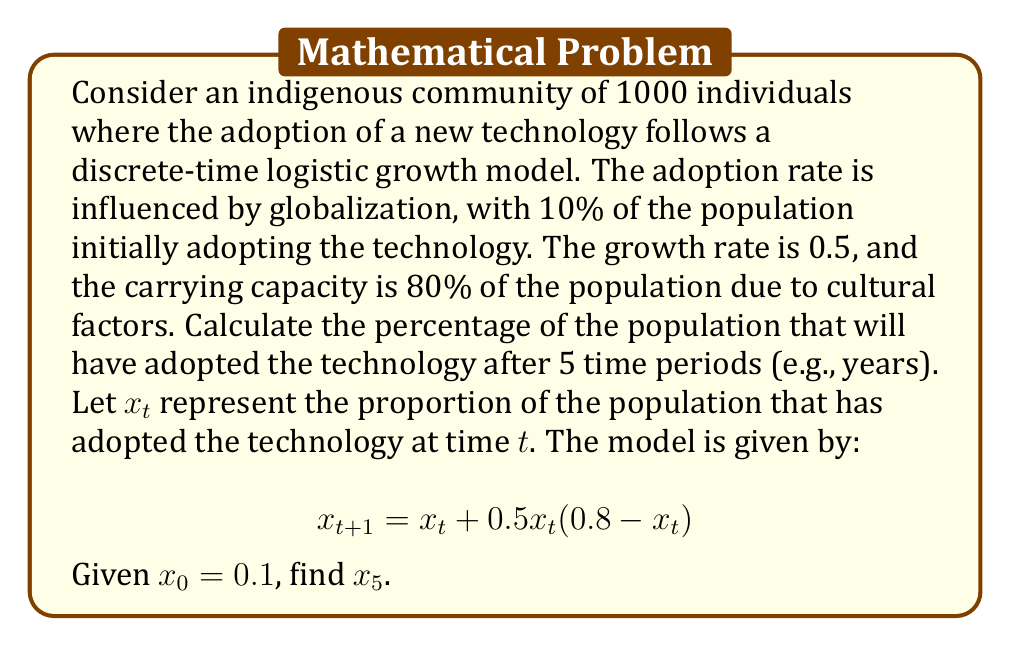Help me with this question. To solve this problem, we need to iterate the given discrete-time dynamical system for 5 time periods. Let's calculate step by step:

1) We start with $x_0 = 0.1$

2) For $t = 0$ to $t = 4$, we calculate $x_{t+1}$ using the formula:
   $$x_{t+1} = x_t + 0.5x_t(0.8 - x_t)$$

3) Let's calculate each step:

   For $t = 0$:
   $$x_1 = 0.1 + 0.5(0.1)(0.8 - 0.1) = 0.1 + 0.035 = 0.135$$

   For $t = 1$:
   $$x_2 = 0.135 + 0.5(0.135)(0.8 - 0.135) = 0.135 + 0.04486875 = 0.17986875$$

   For $t = 2$:
   $$x_3 = 0.17986875 + 0.5(0.17986875)(0.8 - 0.17986875) = 0.23580728$$

   For $t = 3$:
   $$x_4 = 0.23580728 + 0.5(0.23580728)(0.8 - 0.23580728) = 0.30284448$$

   For $t = 4$:
   $$x_5 = 0.30284448 + 0.5(0.30284448)(0.8 - 0.30284448) = 0.37929337$$

4) Therefore, after 5 time periods, $x_5 \approx 0.37929337$

5) To convert this to a percentage, we multiply by 100:
   $0.37929337 * 100 \approx 37.93\%$
Answer: 37.93% 